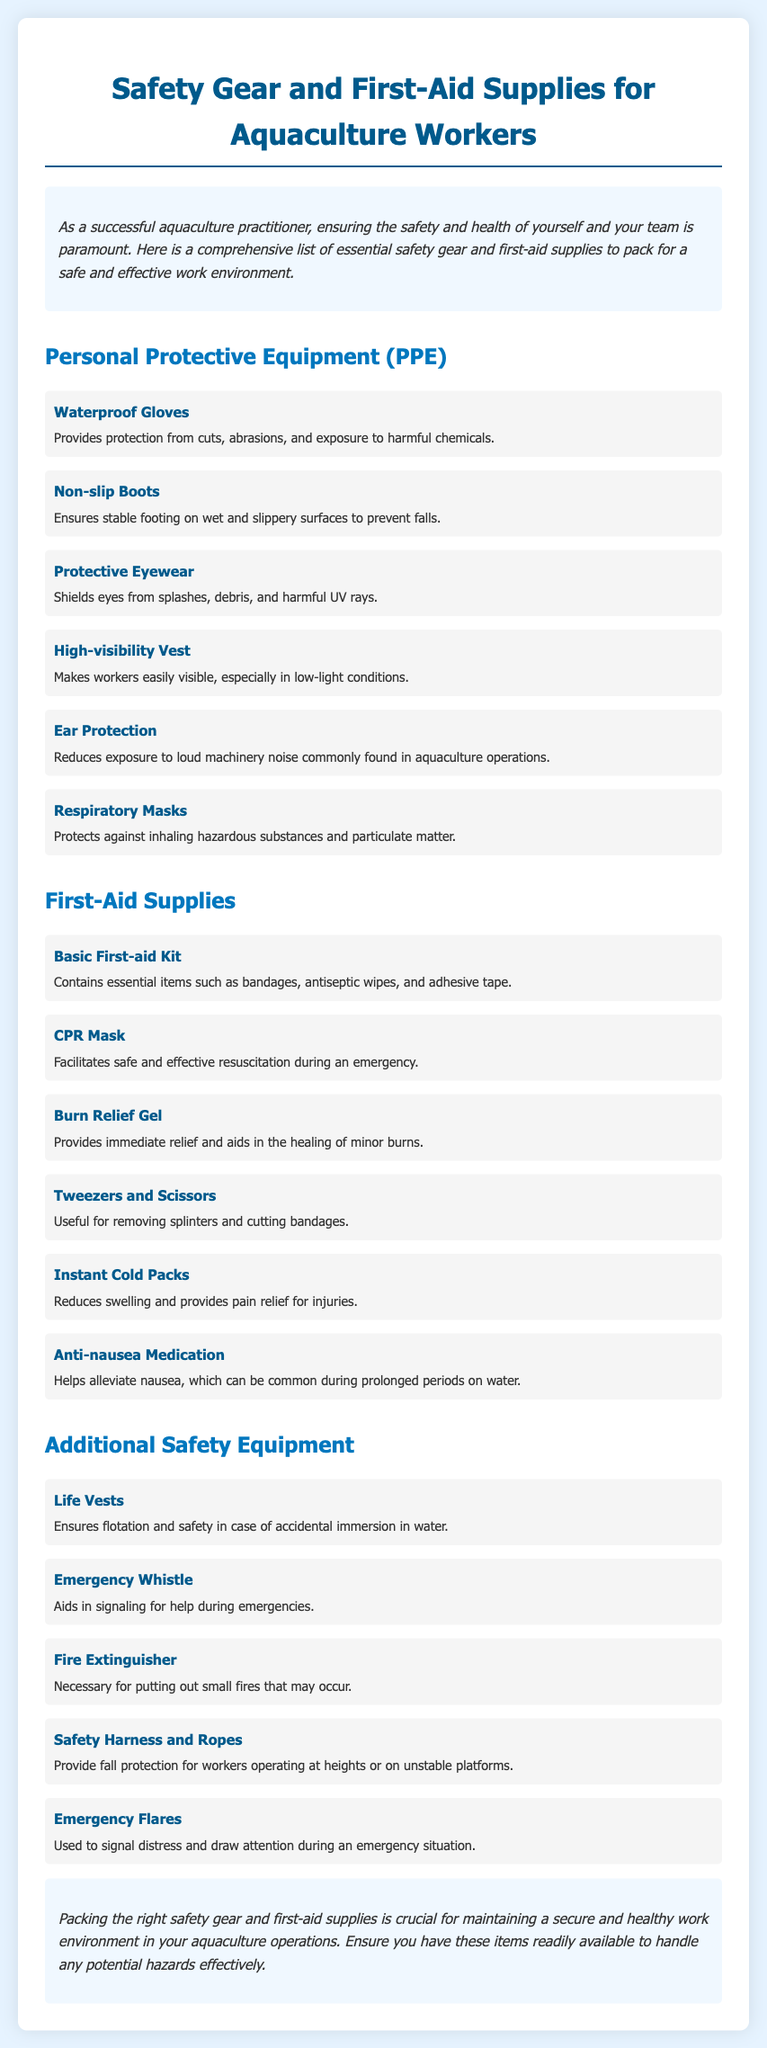what is the first item listed under Personal Protective Equipment? The first item listed is Waterproof Gloves, which protects from cuts, abrasions, and harmful chemicals.
Answer: Waterproof Gloves how many types of First-Aid Supplies are mentioned? There are six types of First-Aid Supplies listed in the document.
Answer: six which item is used to aid in signaling for help during emergencies? The item used for signaling help is the Emergency Whistle, included in the Additional Safety Equipment list.
Answer: Emergency Whistle what does a CPR Mask facilitate? A CPR Mask facilitates safe and effective resuscitation during an emergency, as mentioned in the First-Aid Supplies section.
Answer: resuscitation which type of equipment ensures flotation in case of accidental immersion in water? Life Vests are the equipment mentioned to ensure flotation in case of immersion in water.
Answer: Life Vests what color is suggested for the High-visibility Vest? While the specific color isn't mentioned, it is implied that the vest should be easily visible, typically bright colors like yellow or orange.
Answer: high-visibility which item provides immediate relief for burns? The item that provides immediate relief for burns is Burn Relief Gel, listed in the First-Aid Supplies.
Answer: Burn Relief Gel how many items are listed under Additional Safety Equipment? There are five items listed under Additional Safety Equipment in the document.
Answer: five what is the purpose of Anti-nausea Medication? The purpose of Anti-nausea Medication is to help alleviate nausea during prolonged periods on water, as stated in the First-Aid Supplies section.
Answer: alleviate nausea 